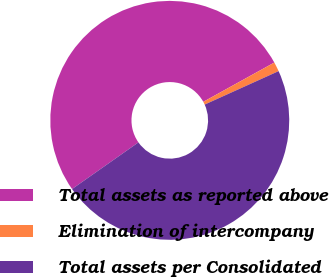Convert chart. <chart><loc_0><loc_0><loc_500><loc_500><pie_chart><fcel>Total assets as reported above<fcel>Elimination of intercompany<fcel>Total assets per Consolidated<nl><fcel>51.71%<fcel>1.28%<fcel>47.01%<nl></chart> 